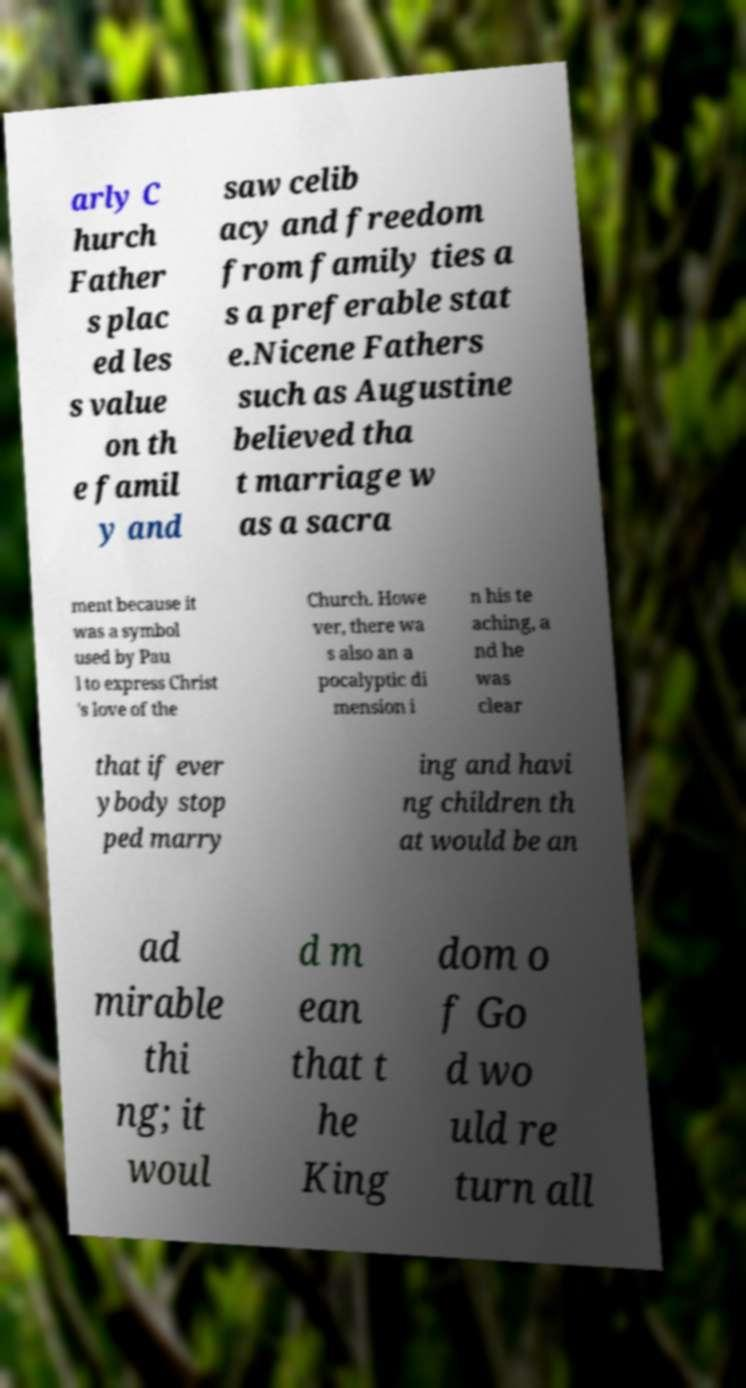Could you assist in decoding the text presented in this image and type it out clearly? arly C hurch Father s plac ed les s value on th e famil y and saw celib acy and freedom from family ties a s a preferable stat e.Nicene Fathers such as Augustine believed tha t marriage w as a sacra ment because it was a symbol used by Pau l to express Christ 's love of the Church. Howe ver, there wa s also an a pocalyptic di mension i n his te aching, a nd he was clear that if ever ybody stop ped marry ing and havi ng children th at would be an ad mirable thi ng; it woul d m ean that t he King dom o f Go d wo uld re turn all 